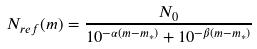Convert formula to latex. <formula><loc_0><loc_0><loc_500><loc_500>N _ { r e f } ( m ) = \frac { N _ { 0 } } { 1 0 ^ { - \alpha ( m - m _ { * } ) } + 1 0 ^ { - \beta ( m - m _ { * } ) } }</formula> 